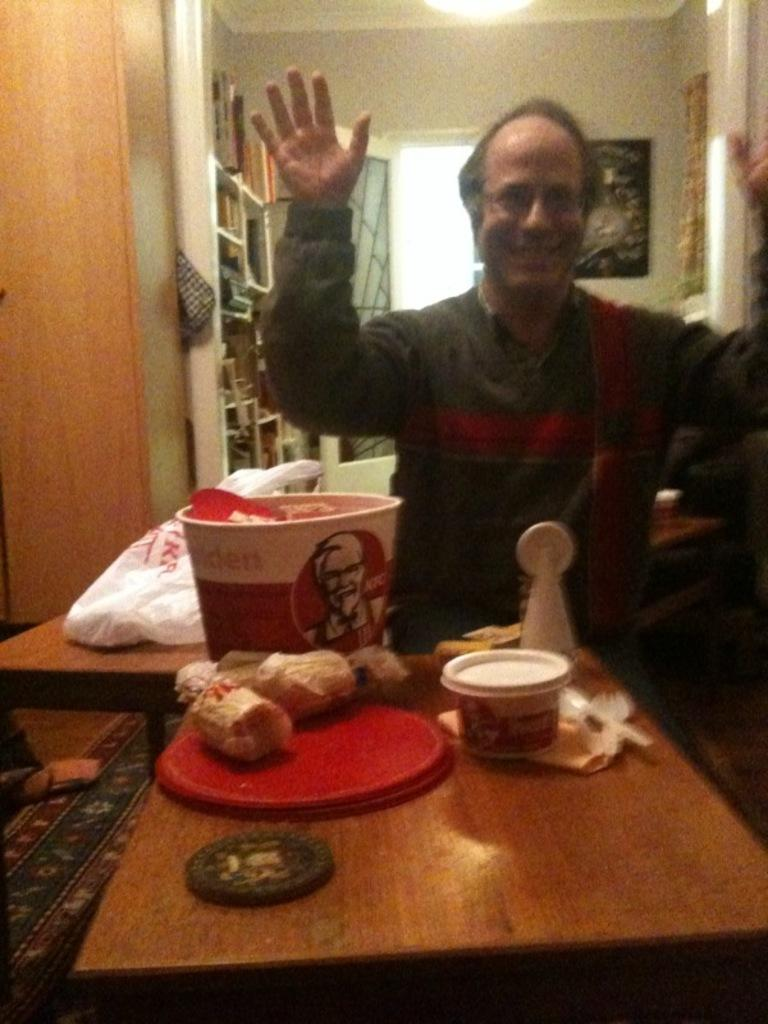Who is present in the image? There is a man in the image. What is the man doing in the image? The man is sitting at a table. What can be seen on the table in the image? There are eatables on the table. What is the man's reaction to the suggestion of having dinner in the image? There is no mention of a suggestion or dinner in the image, so it is not possible to determine the man's reaction. 